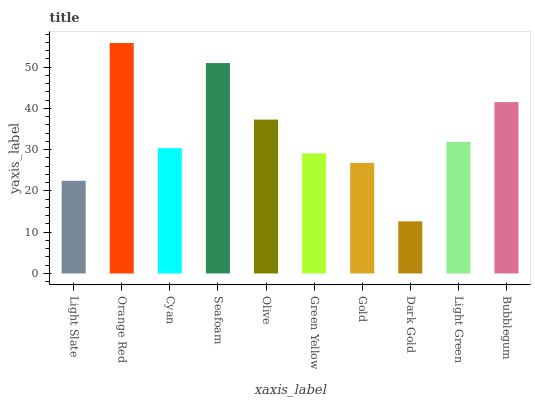Is Dark Gold the minimum?
Answer yes or no. Yes. Is Orange Red the maximum?
Answer yes or no. Yes. Is Cyan the minimum?
Answer yes or no. No. Is Cyan the maximum?
Answer yes or no. No. Is Orange Red greater than Cyan?
Answer yes or no. Yes. Is Cyan less than Orange Red?
Answer yes or no. Yes. Is Cyan greater than Orange Red?
Answer yes or no. No. Is Orange Red less than Cyan?
Answer yes or no. No. Is Light Green the high median?
Answer yes or no. Yes. Is Cyan the low median?
Answer yes or no. Yes. Is Orange Red the high median?
Answer yes or no. No. Is Gold the low median?
Answer yes or no. No. 